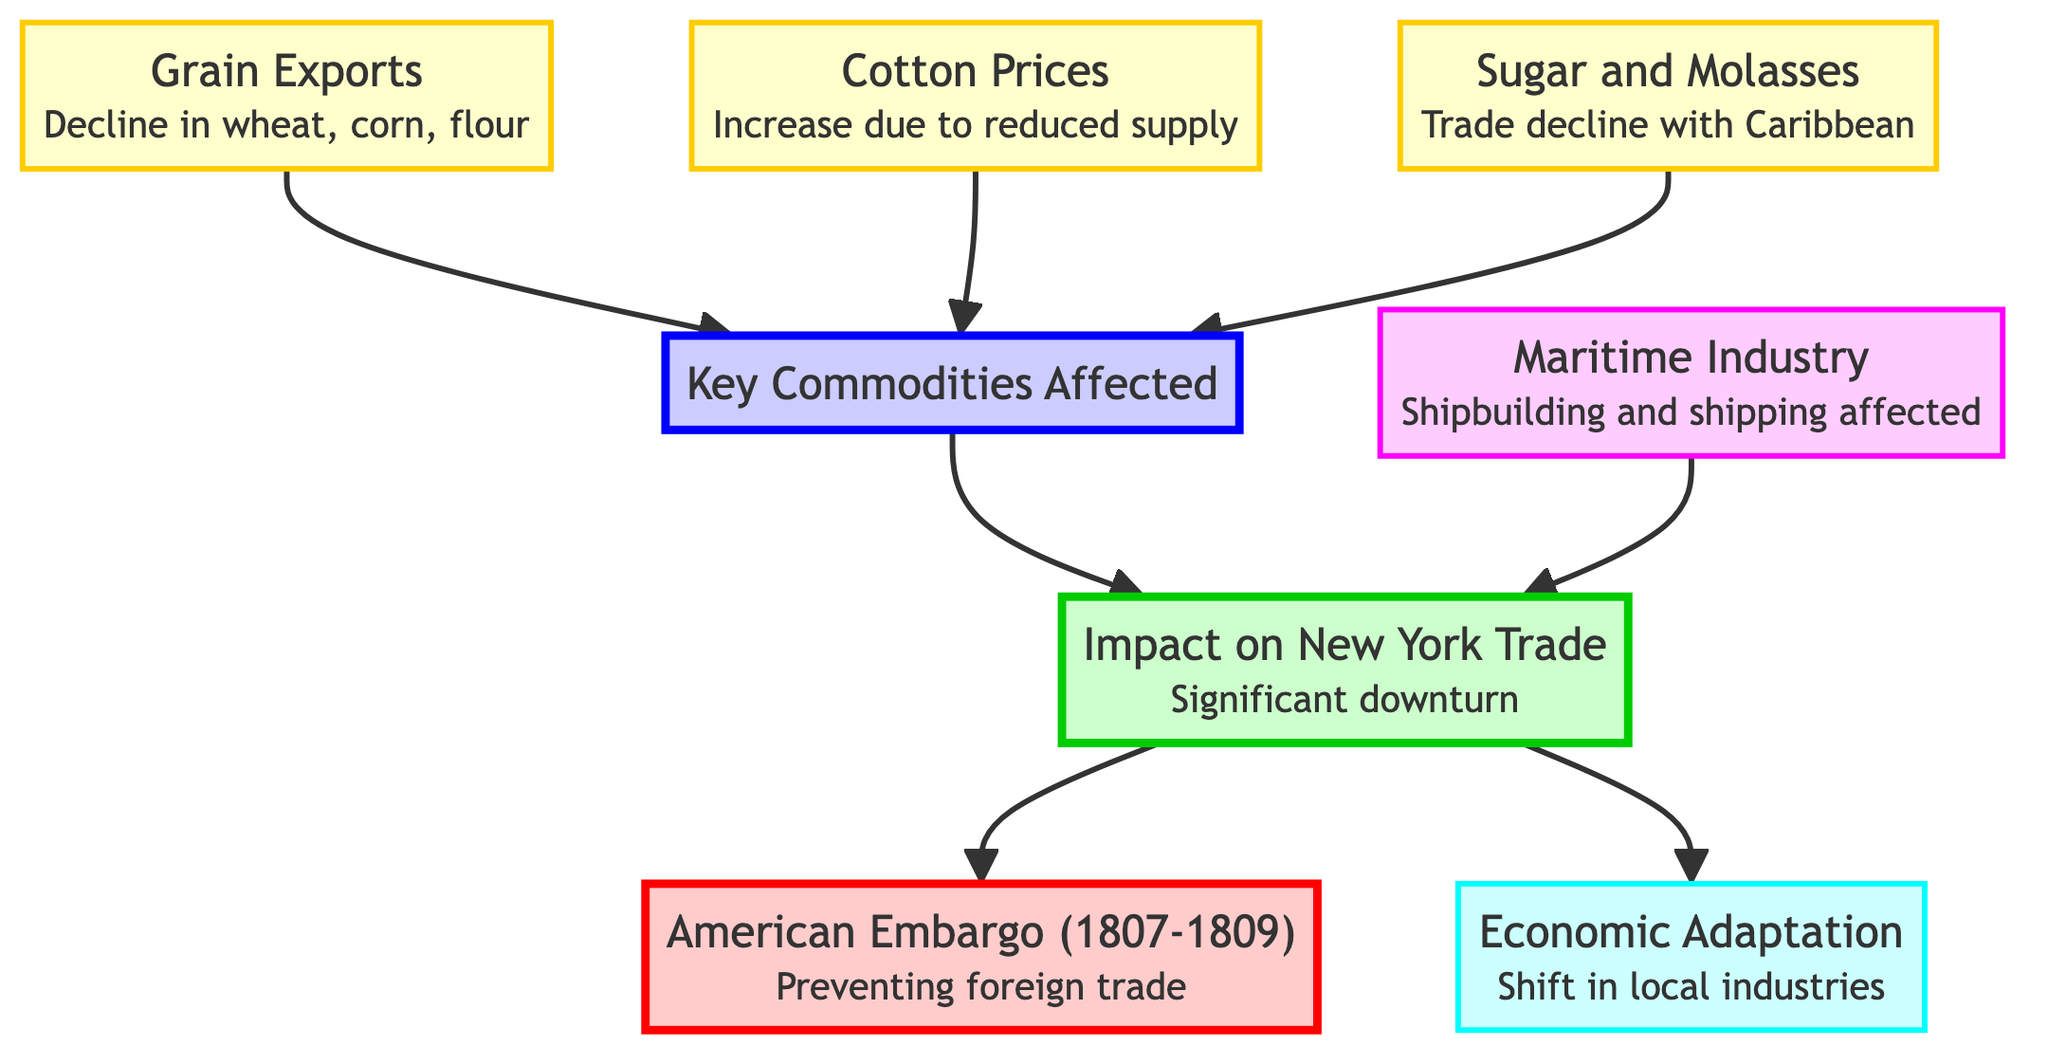What event initiated the trade restrictions in New York? The diagram identifies the top node, "American Embargo (1807-1809)", as the event that led to trade restrictions, highlighting its significance in the context of New York trade.
Answer: American Embargo (1807-1809) What is the impact of the embargo on New York's trade? The next node down, "Impact on New York Trade", describes the effect as a "Significant downturn in trade activities within New York City due to embargo restrictions." This directly indicates how the embargo affected trade in the city.
Answer: Significant downturn in trade activities How many key commodities are listed as affected by the embargo? By examining the connections leading to the "Key Commodities Affected" node, we see there are three linked nodes (Grain Exports, Cotton Prices, Sugar and Molasses) that indicate the major commodities impacted by the embargo.
Answer: 3 Which commodity saw an increase in prices according to the diagram? The "Cotton Prices" node states that there was an "Increase in cotton prices due to reduced supply from Southern states," directly answering which commodity's price increased.
Answer: Cotton Prices What sector was severely affected due to the loss of overseas trade? According to the diagram, the "Maritime Industry" node specifically mentions the impact on "Shipbuilding and shipping sectors severely affected by the loss of overseas trade," making clear the sector impacted.
Answer: Maritime Industry What is the response of the local industries to the embargo? The node "Economic Adaptation" clearly states that there was a "Shift in local industries seeking new markets or goods consumption," indicating how the local industries reacted to the embargo.
Answer: Economic Adaptation How many sectors are specifically mentioned in the diagram? The diagram includes one sector, which is the "Maritime Industry," as indicated under the corresponding node that defines this sector's impact.
Answer: 1 What led to the decline in grain exports? From examining the node "Grain Exports," it describes a "Decline in exports of wheat, corn, and flour," emphasizing that these specific grains contributed to the overall drop in exports due to embargo restrictions.
Answer: Decline in exports of wheat, corn, and flour 